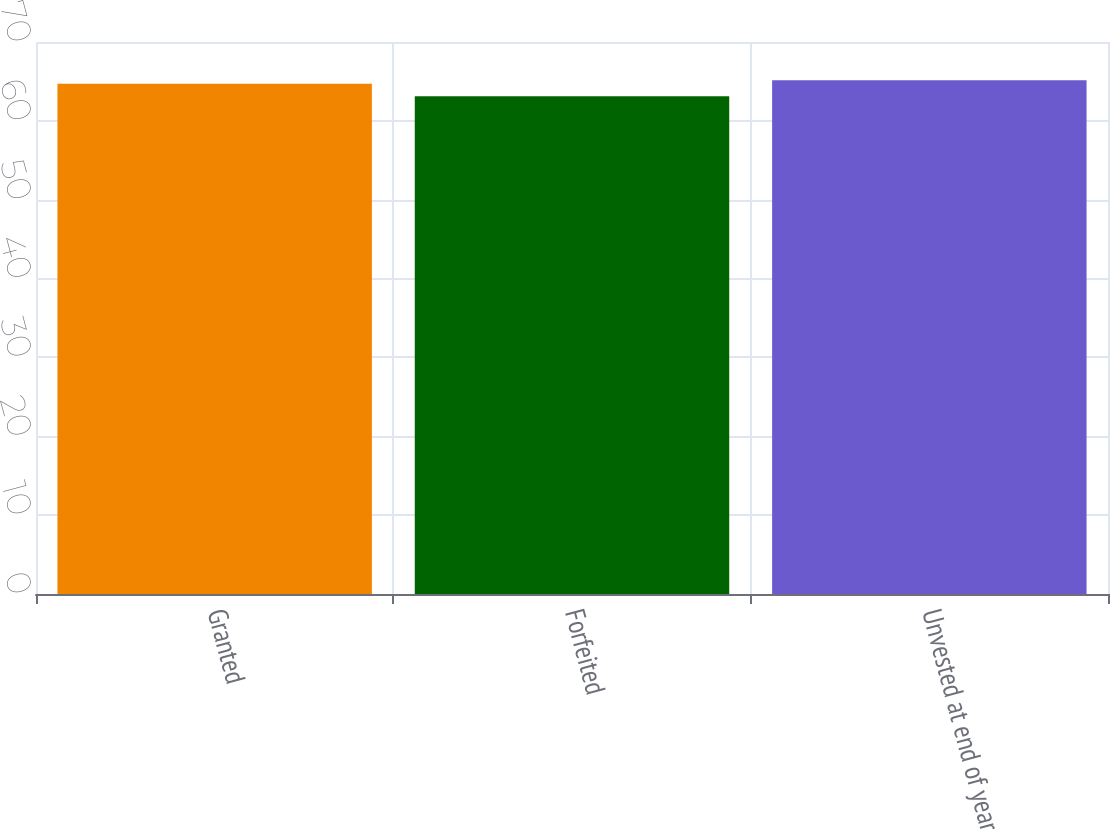Convert chart. <chart><loc_0><loc_0><loc_500><loc_500><bar_chart><fcel>Granted<fcel>Forfeited<fcel>Unvested at end of year<nl><fcel>64.71<fcel>63.12<fcel>65.14<nl></chart> 